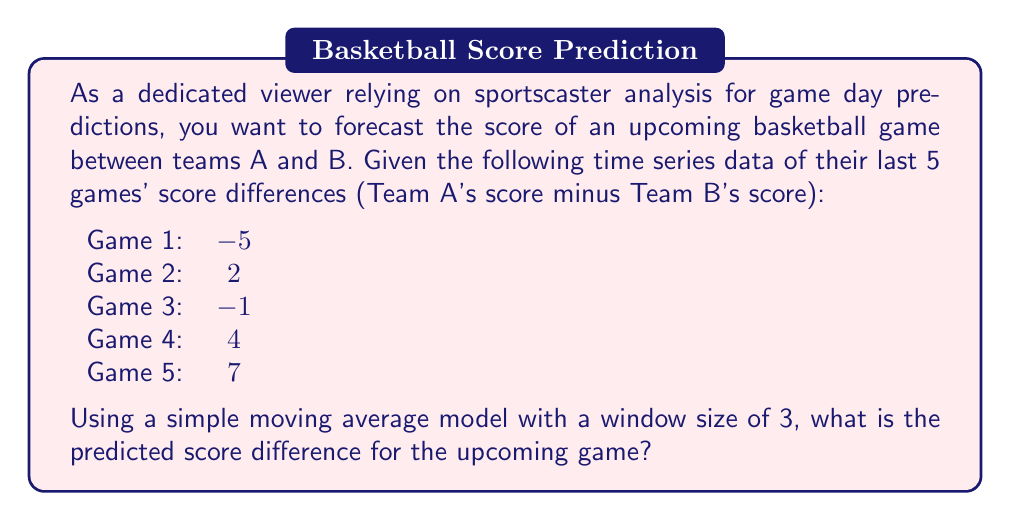Can you answer this question? To solve this problem, we'll use a simple moving average (SMA) model with a window size of 3. This means we'll calculate the average of the last 3 data points to predict the next value in the time series.

Step 1: Identify the last 3 data points in the series:
Game 3: -1
Game 4: 4
Game 5: 7

Step 2: Calculate the simple moving average:
$$ SMA = \frac{-1 + 4 + 7}{3} = \frac{10}{3} \approx 3.33 $$

Step 3: Interpret the result:
The SMA of 3.33 suggests that, based on the recent trend, Team A is expected to outscore Team B by approximately 3.33 points in the upcoming game.

Note: This is a basic forecasting method and doesn't account for many factors that could influence the game's outcome. More sophisticated time series models like ARIMA or exponential smoothing might provide more accurate predictions when considering longer historical data and other variables.
Answer: The predicted score difference for the upcoming game, using a simple moving average model with a window size of 3, is approximately 3.33 points in favor of Team A. 